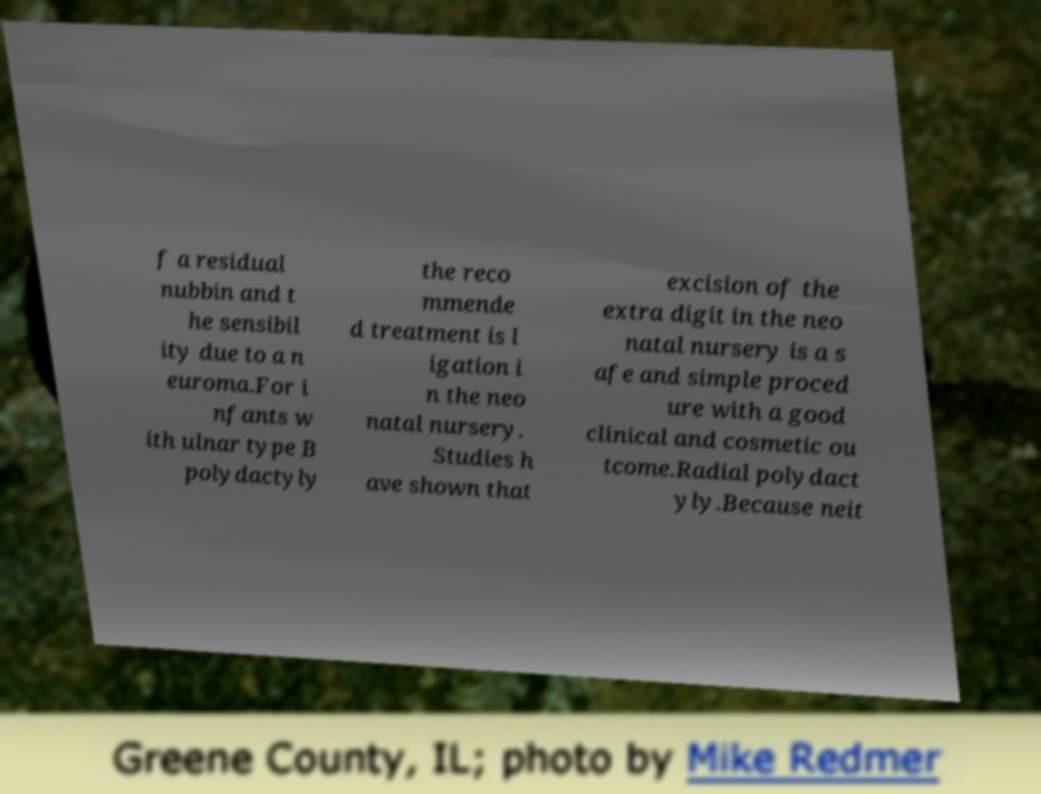For documentation purposes, I need the text within this image transcribed. Could you provide that? f a residual nubbin and t he sensibil ity due to a n euroma.For i nfants w ith ulnar type B polydactyly the reco mmende d treatment is l igation i n the neo natal nursery. Studies h ave shown that excision of the extra digit in the neo natal nursery is a s afe and simple proced ure with a good clinical and cosmetic ou tcome.Radial polydact yly.Because neit 